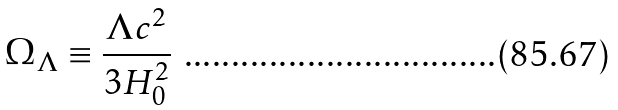Convert formula to latex. <formula><loc_0><loc_0><loc_500><loc_500>\Omega _ { \Lambda } \equiv \frac { \Lambda c ^ { 2 } } { 3 H _ { 0 } ^ { 2 } }</formula> 